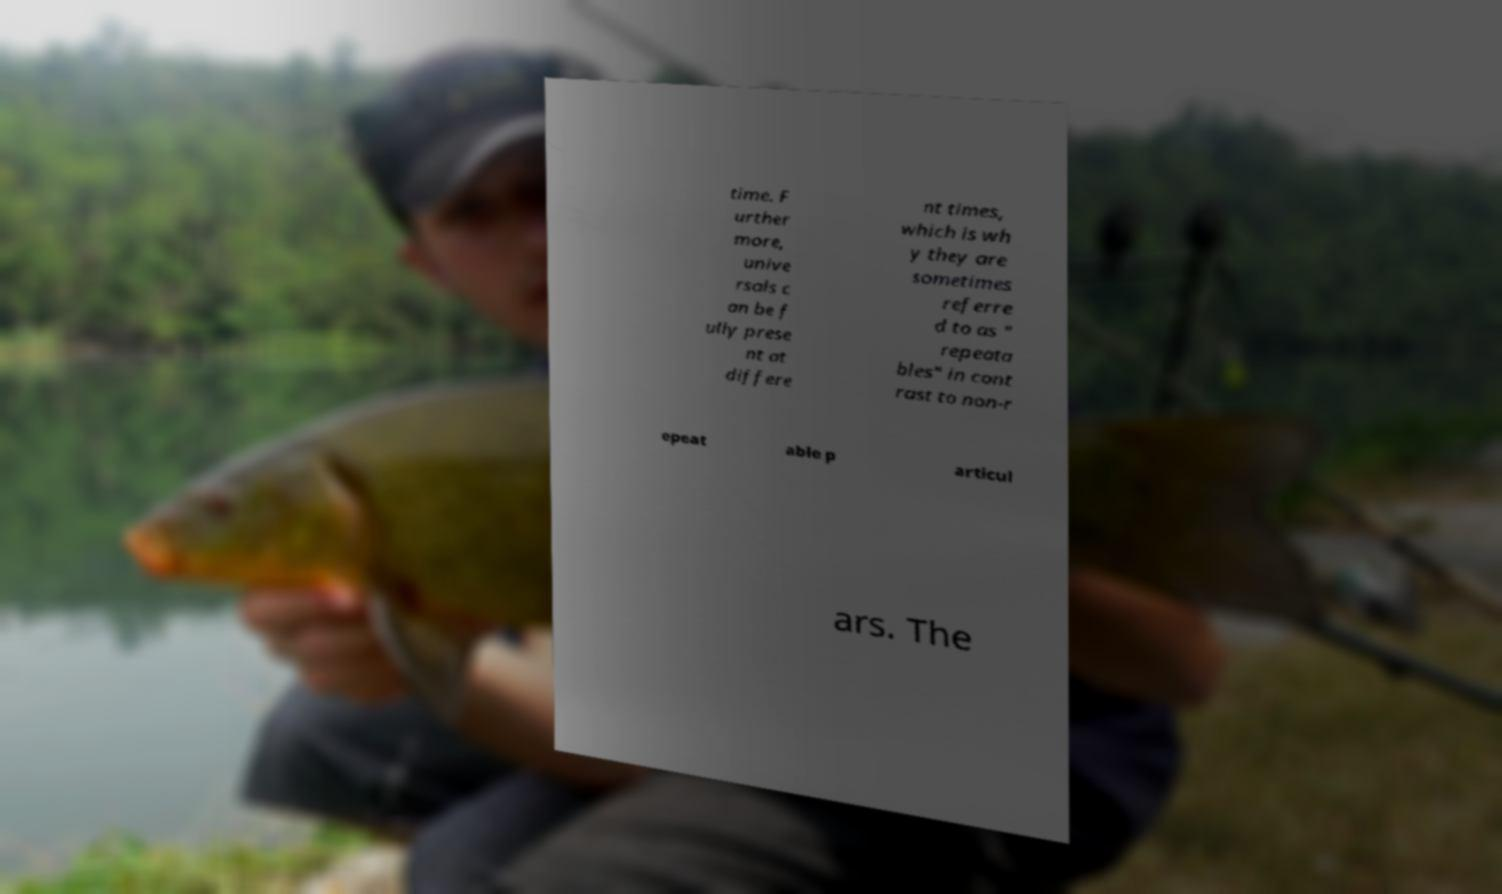I need the written content from this picture converted into text. Can you do that? time. F urther more, unive rsals c an be f ully prese nt at differe nt times, which is wh y they are sometimes referre d to as " repeata bles" in cont rast to non-r epeat able p articul ars. The 